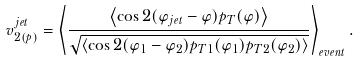Convert formula to latex. <formula><loc_0><loc_0><loc_500><loc_500>v ^ { j e t } _ { 2 ( p ) } = \left < \frac { \left < \cos { 2 ( \varphi _ { j e t } - \varphi ) } p _ { T } ( \varphi ) \right > } { \sqrt { \left < \cos { 2 ( \varphi _ { 1 } - \varphi _ { 2 } ) } p _ { T 1 } ( \varphi _ { 1 } ) p _ { T 2 } ( \varphi _ { 2 } ) \right > } } \right > _ { e v e n t } .</formula> 